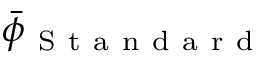<formula> <loc_0><loc_0><loc_500><loc_500>\bar { \phi } _ { S t a n d a r d }</formula> 